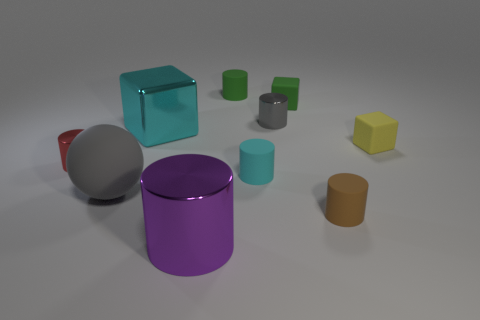What number of objects are either small shiny objects right of the cyan matte cylinder or big red matte cubes?
Give a very brief answer. 1. Is the number of tiny gray cylinders behind the brown thing the same as the number of green rubber objects?
Provide a succinct answer. No. Do the big shiny cylinder and the sphere have the same color?
Provide a succinct answer. No. The large object that is in front of the metallic cube and to the left of the purple object is what color?
Your answer should be very brief. Gray. What number of spheres are either big things or shiny things?
Offer a very short reply. 1. Are there fewer big gray spheres to the right of the cyan cube than yellow things?
Make the answer very short. Yes. There is a purple thing that is the same material as the red cylinder; what is its shape?
Keep it short and to the point. Cylinder. How many other rubber cylinders are the same color as the big cylinder?
Make the answer very short. 0. How many things are either green rubber blocks or cyan rubber cylinders?
Keep it short and to the point. 2. There is a tiny green object that is to the left of the small matte block behind the tiny gray shiny object; what is it made of?
Offer a terse response. Rubber. 